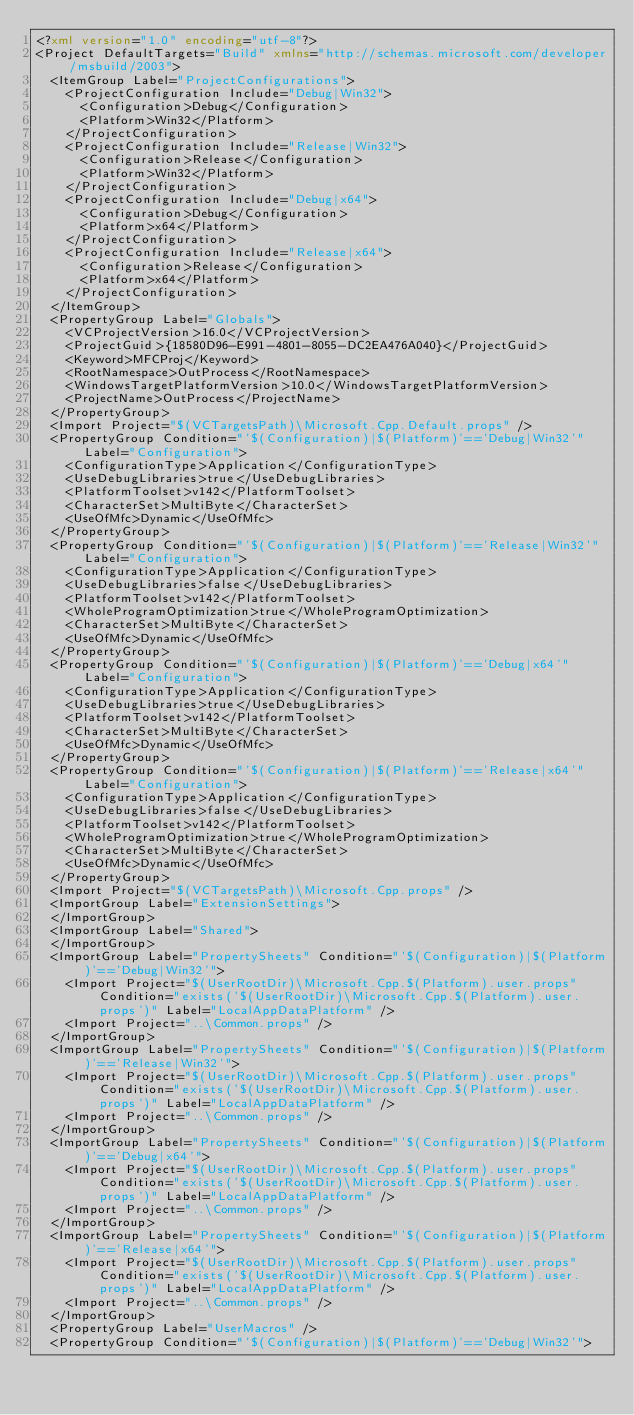Convert code to text. <code><loc_0><loc_0><loc_500><loc_500><_XML_><?xml version="1.0" encoding="utf-8"?>
<Project DefaultTargets="Build" xmlns="http://schemas.microsoft.com/developer/msbuild/2003">
  <ItemGroup Label="ProjectConfigurations">
    <ProjectConfiguration Include="Debug|Win32">
      <Configuration>Debug</Configuration>
      <Platform>Win32</Platform>
    </ProjectConfiguration>
    <ProjectConfiguration Include="Release|Win32">
      <Configuration>Release</Configuration>
      <Platform>Win32</Platform>
    </ProjectConfiguration>
    <ProjectConfiguration Include="Debug|x64">
      <Configuration>Debug</Configuration>
      <Platform>x64</Platform>
    </ProjectConfiguration>
    <ProjectConfiguration Include="Release|x64">
      <Configuration>Release</Configuration>
      <Platform>x64</Platform>
    </ProjectConfiguration>
  </ItemGroup>
  <PropertyGroup Label="Globals">
    <VCProjectVersion>16.0</VCProjectVersion>
    <ProjectGuid>{18580D96-E991-4801-8055-DC2EA476A040}</ProjectGuid>
    <Keyword>MFCProj</Keyword>
    <RootNamespace>OutProcess</RootNamespace>
    <WindowsTargetPlatformVersion>10.0</WindowsTargetPlatformVersion>
    <ProjectName>OutProcess</ProjectName>
  </PropertyGroup>
  <Import Project="$(VCTargetsPath)\Microsoft.Cpp.Default.props" />
  <PropertyGroup Condition="'$(Configuration)|$(Platform)'=='Debug|Win32'" Label="Configuration">
    <ConfigurationType>Application</ConfigurationType>
    <UseDebugLibraries>true</UseDebugLibraries>
    <PlatformToolset>v142</PlatformToolset>
    <CharacterSet>MultiByte</CharacterSet>
    <UseOfMfc>Dynamic</UseOfMfc>
  </PropertyGroup>
  <PropertyGroup Condition="'$(Configuration)|$(Platform)'=='Release|Win32'" Label="Configuration">
    <ConfigurationType>Application</ConfigurationType>
    <UseDebugLibraries>false</UseDebugLibraries>
    <PlatformToolset>v142</PlatformToolset>
    <WholeProgramOptimization>true</WholeProgramOptimization>
    <CharacterSet>MultiByte</CharacterSet>
    <UseOfMfc>Dynamic</UseOfMfc>
  </PropertyGroup>
  <PropertyGroup Condition="'$(Configuration)|$(Platform)'=='Debug|x64'" Label="Configuration">
    <ConfigurationType>Application</ConfigurationType>
    <UseDebugLibraries>true</UseDebugLibraries>
    <PlatformToolset>v142</PlatformToolset>
    <CharacterSet>MultiByte</CharacterSet>
    <UseOfMfc>Dynamic</UseOfMfc>
  </PropertyGroup>
  <PropertyGroup Condition="'$(Configuration)|$(Platform)'=='Release|x64'" Label="Configuration">
    <ConfigurationType>Application</ConfigurationType>
    <UseDebugLibraries>false</UseDebugLibraries>
    <PlatformToolset>v142</PlatformToolset>
    <WholeProgramOptimization>true</WholeProgramOptimization>
    <CharacterSet>MultiByte</CharacterSet>
    <UseOfMfc>Dynamic</UseOfMfc>
  </PropertyGroup>
  <Import Project="$(VCTargetsPath)\Microsoft.Cpp.props" />
  <ImportGroup Label="ExtensionSettings">
  </ImportGroup>
  <ImportGroup Label="Shared">
  </ImportGroup>
  <ImportGroup Label="PropertySheets" Condition="'$(Configuration)|$(Platform)'=='Debug|Win32'">
    <Import Project="$(UserRootDir)\Microsoft.Cpp.$(Platform).user.props" Condition="exists('$(UserRootDir)\Microsoft.Cpp.$(Platform).user.props')" Label="LocalAppDataPlatform" />
    <Import Project="..\Common.props" />
  </ImportGroup>
  <ImportGroup Label="PropertySheets" Condition="'$(Configuration)|$(Platform)'=='Release|Win32'">
    <Import Project="$(UserRootDir)\Microsoft.Cpp.$(Platform).user.props" Condition="exists('$(UserRootDir)\Microsoft.Cpp.$(Platform).user.props')" Label="LocalAppDataPlatform" />
    <Import Project="..\Common.props" />
  </ImportGroup>
  <ImportGroup Label="PropertySheets" Condition="'$(Configuration)|$(Platform)'=='Debug|x64'">
    <Import Project="$(UserRootDir)\Microsoft.Cpp.$(Platform).user.props" Condition="exists('$(UserRootDir)\Microsoft.Cpp.$(Platform).user.props')" Label="LocalAppDataPlatform" />
    <Import Project="..\Common.props" />
  </ImportGroup>
  <ImportGroup Label="PropertySheets" Condition="'$(Configuration)|$(Platform)'=='Release|x64'">
    <Import Project="$(UserRootDir)\Microsoft.Cpp.$(Platform).user.props" Condition="exists('$(UserRootDir)\Microsoft.Cpp.$(Platform).user.props')" Label="LocalAppDataPlatform" />
    <Import Project="..\Common.props" />
  </ImportGroup>
  <PropertyGroup Label="UserMacros" />
  <PropertyGroup Condition="'$(Configuration)|$(Platform)'=='Debug|Win32'"></code> 